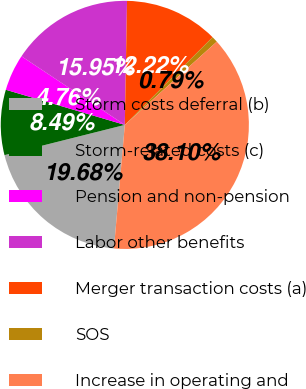Convert chart to OTSL. <chart><loc_0><loc_0><loc_500><loc_500><pie_chart><fcel>Storm costs deferral (b)<fcel>Storm-related costs (c)<fcel>Pension and non-pension<fcel>Labor other benefits<fcel>Merger transaction costs (a)<fcel>SOS<fcel>Increase in operating and<nl><fcel>19.68%<fcel>8.49%<fcel>4.76%<fcel>15.95%<fcel>12.22%<fcel>0.79%<fcel>38.1%<nl></chart> 